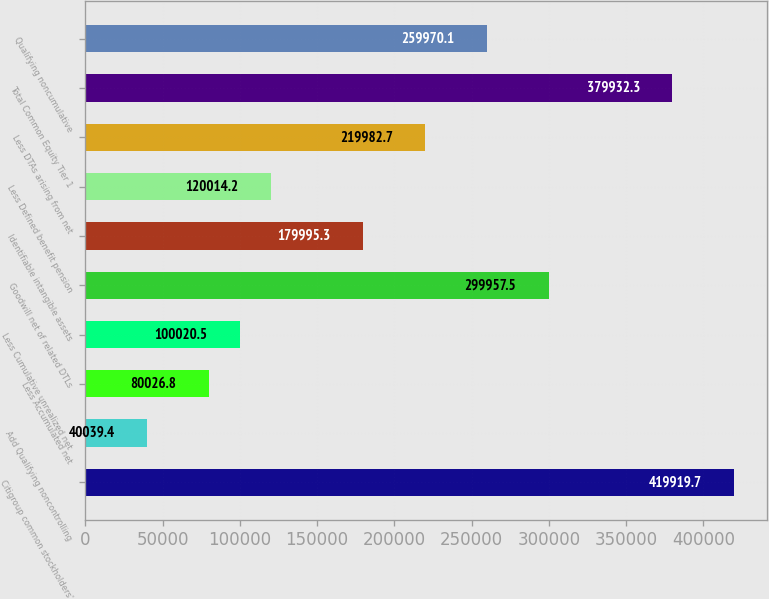<chart> <loc_0><loc_0><loc_500><loc_500><bar_chart><fcel>Citigroup common stockholders'<fcel>Add Qualifying noncontrolling<fcel>Less Accumulated net<fcel>Less Cumulative unrealized net<fcel>Goodwill net of related DTLs<fcel>Identifiable intangible assets<fcel>Less Defined benefit pension<fcel>Less DTAs arising from net<fcel>Total Common Equity Tier 1<fcel>Qualifying noncumulative<nl><fcel>419920<fcel>40039.4<fcel>80026.8<fcel>100020<fcel>299958<fcel>179995<fcel>120014<fcel>219983<fcel>379932<fcel>259970<nl></chart> 